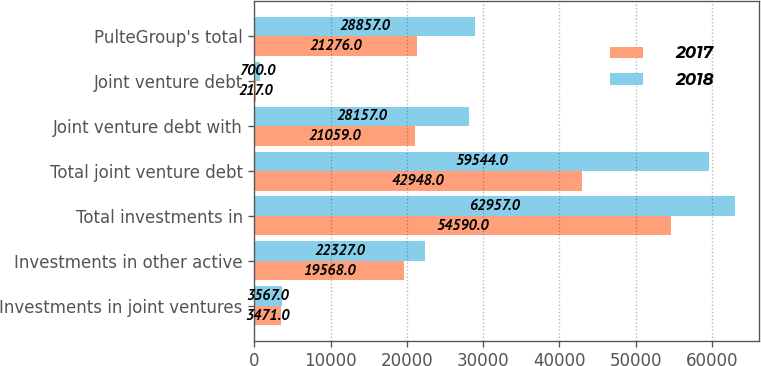Convert chart to OTSL. <chart><loc_0><loc_0><loc_500><loc_500><stacked_bar_chart><ecel><fcel>Investments in joint ventures<fcel>Investments in other active<fcel>Total investments in<fcel>Total joint venture debt<fcel>Joint venture debt with<fcel>Joint venture debt<fcel>PulteGroup's total<nl><fcel>2017<fcel>3471<fcel>19568<fcel>54590<fcel>42948<fcel>21059<fcel>217<fcel>21276<nl><fcel>2018<fcel>3567<fcel>22327<fcel>62957<fcel>59544<fcel>28157<fcel>700<fcel>28857<nl></chart> 